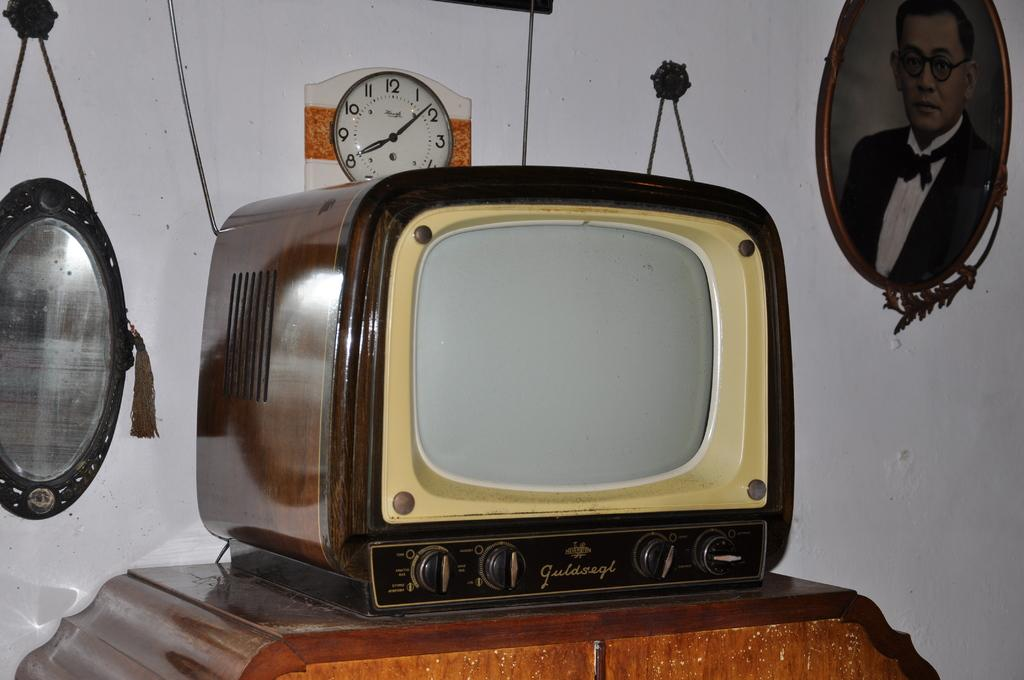<image>
Give a short and clear explanation of the subsequent image. A TV is branded with the name Guldsegl. 